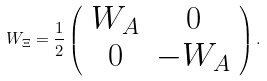<formula> <loc_0><loc_0><loc_500><loc_500>W _ { \Xi } = \frac { 1 } { 2 } \left ( \begin{array} { c c } W _ { A } & 0 \\ 0 & - W _ { A } \\ \end{array} \right ) .</formula> 